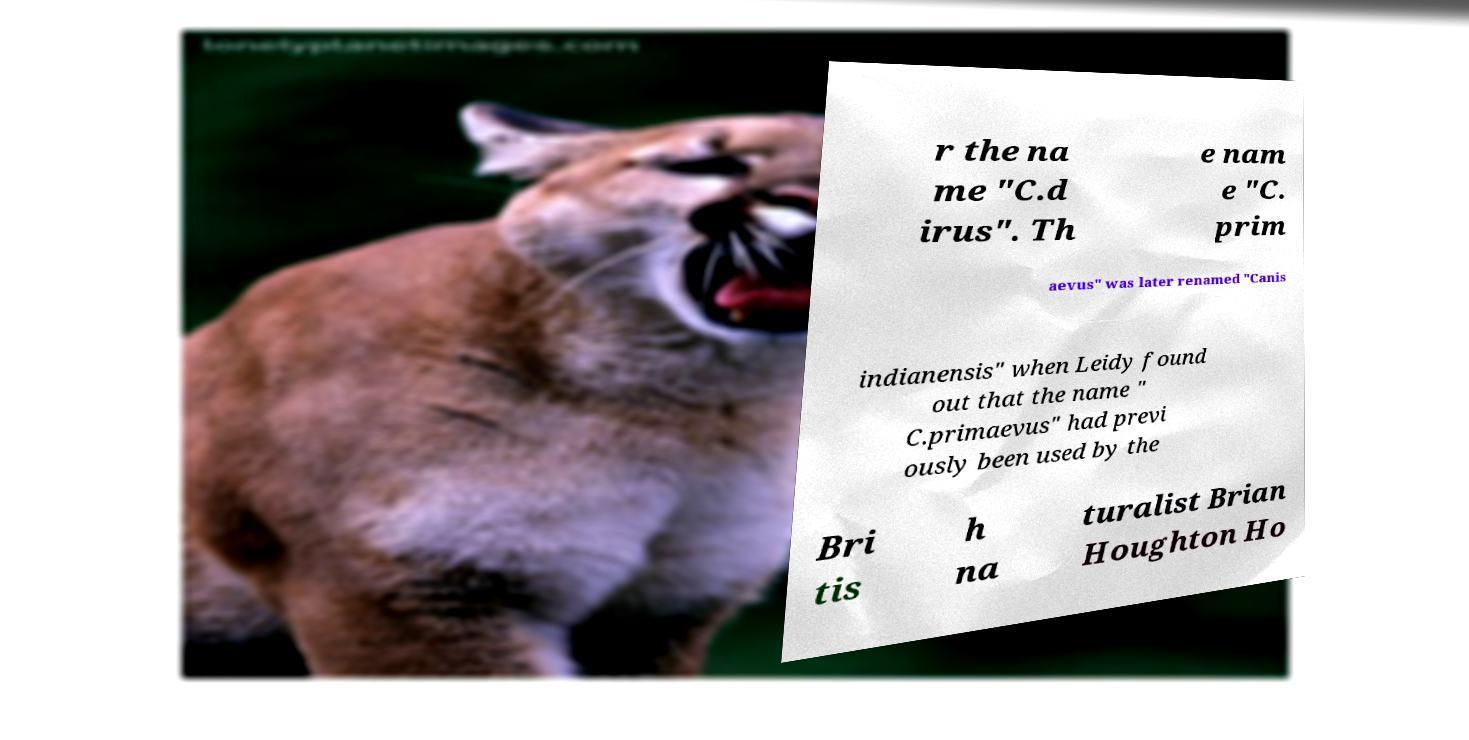Could you assist in decoding the text presented in this image and type it out clearly? r the na me "C.d irus". Th e nam e "C. prim aevus" was later renamed "Canis indianensis" when Leidy found out that the name " C.primaevus" had previ ously been used by the Bri tis h na turalist Brian Houghton Ho 